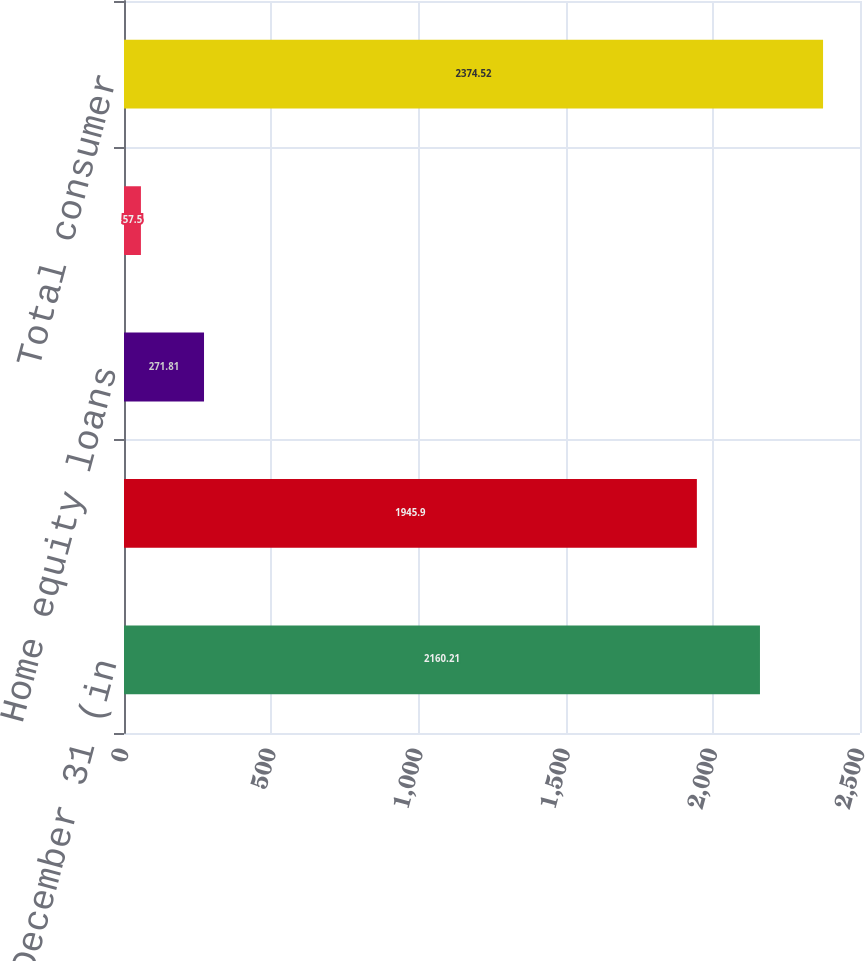Convert chart to OTSL. <chart><loc_0><loc_0><loc_500><loc_500><bar_chart><fcel>As of December 31 (in<fcel>Home equity lines of credit<fcel>Home equity loans<fcel>Other<fcel>Total consumer<nl><fcel>2160.21<fcel>1945.9<fcel>271.81<fcel>57.5<fcel>2374.52<nl></chart> 